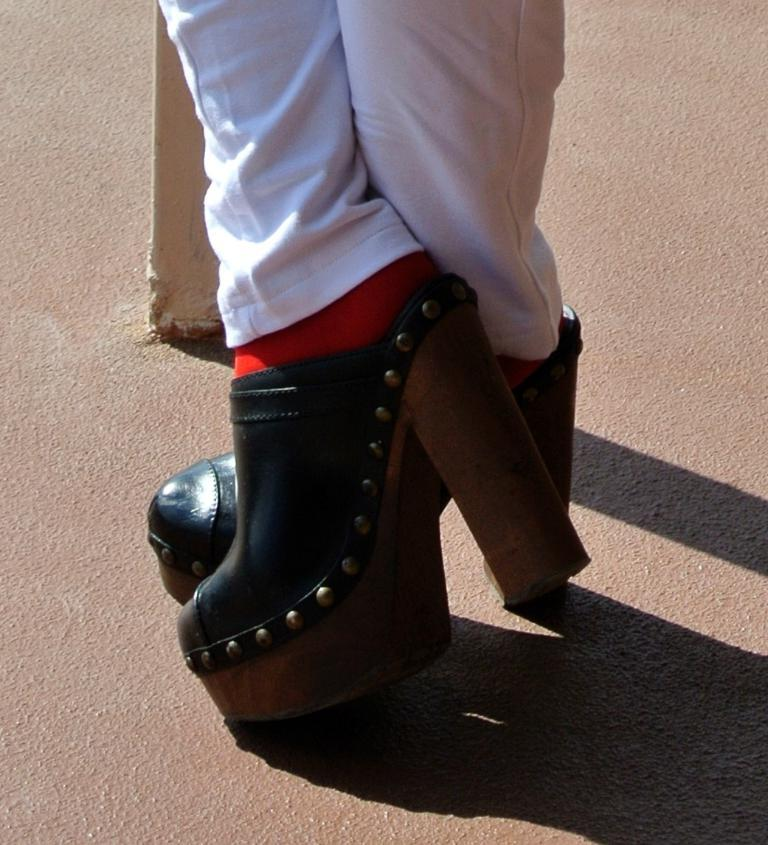What part of a person can be seen in the image? There are legs of a person visible in the image. What is the person wearing on their feet in the image? Footwear is present in the image. What type of surface is visible behind the person in the image? There is ground visible behind the person in the image. How many oranges are being washed in the sink in the image? There is no sink or oranges present in the image. 